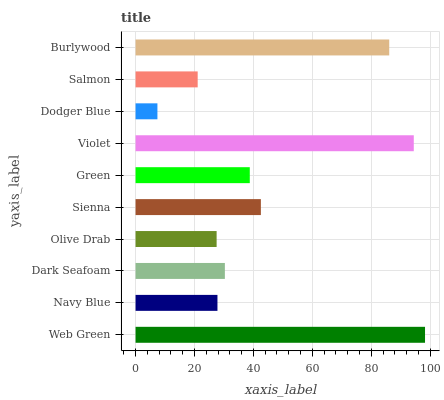Is Dodger Blue the minimum?
Answer yes or no. Yes. Is Web Green the maximum?
Answer yes or no. Yes. Is Navy Blue the minimum?
Answer yes or no. No. Is Navy Blue the maximum?
Answer yes or no. No. Is Web Green greater than Navy Blue?
Answer yes or no. Yes. Is Navy Blue less than Web Green?
Answer yes or no. Yes. Is Navy Blue greater than Web Green?
Answer yes or no. No. Is Web Green less than Navy Blue?
Answer yes or no. No. Is Green the high median?
Answer yes or no. Yes. Is Dark Seafoam the low median?
Answer yes or no. Yes. Is Burlywood the high median?
Answer yes or no. No. Is Violet the low median?
Answer yes or no. No. 